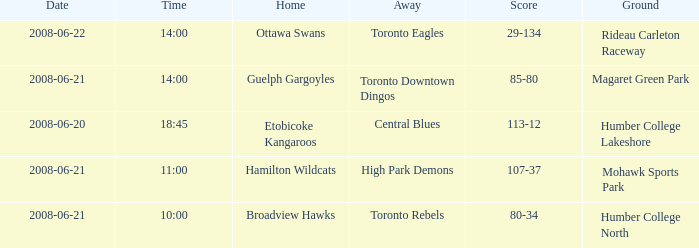What is the ground with a date that is 2008-06-20? Humber College Lakeshore. 